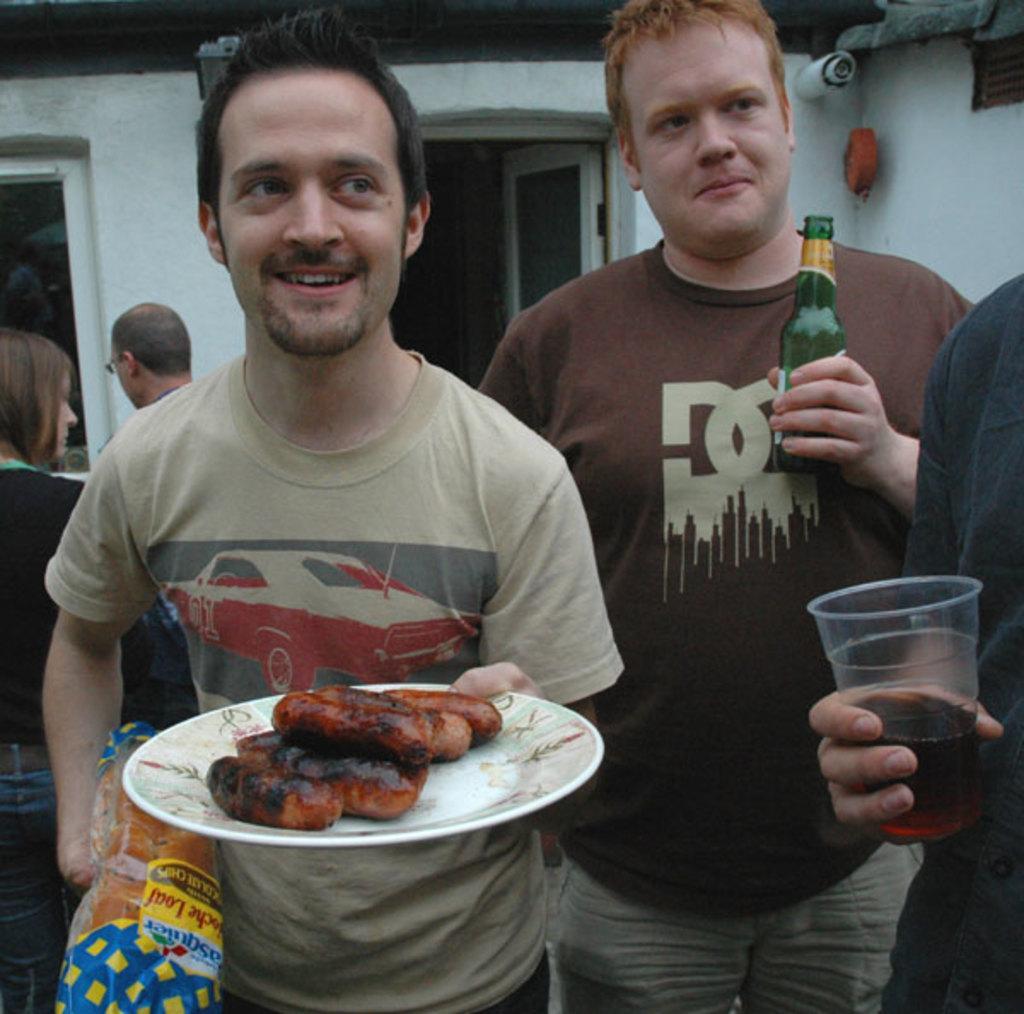Please provide a concise description of this image. In this picture we can see few people, on the left side of the image we can see a man, he is holding a plate and a cover, we can see food in the plate, beside him we can find another man, he is holding a bottle, on the right side of the image we can see a person and the person is holding a glass, we can see drink in the glass. 